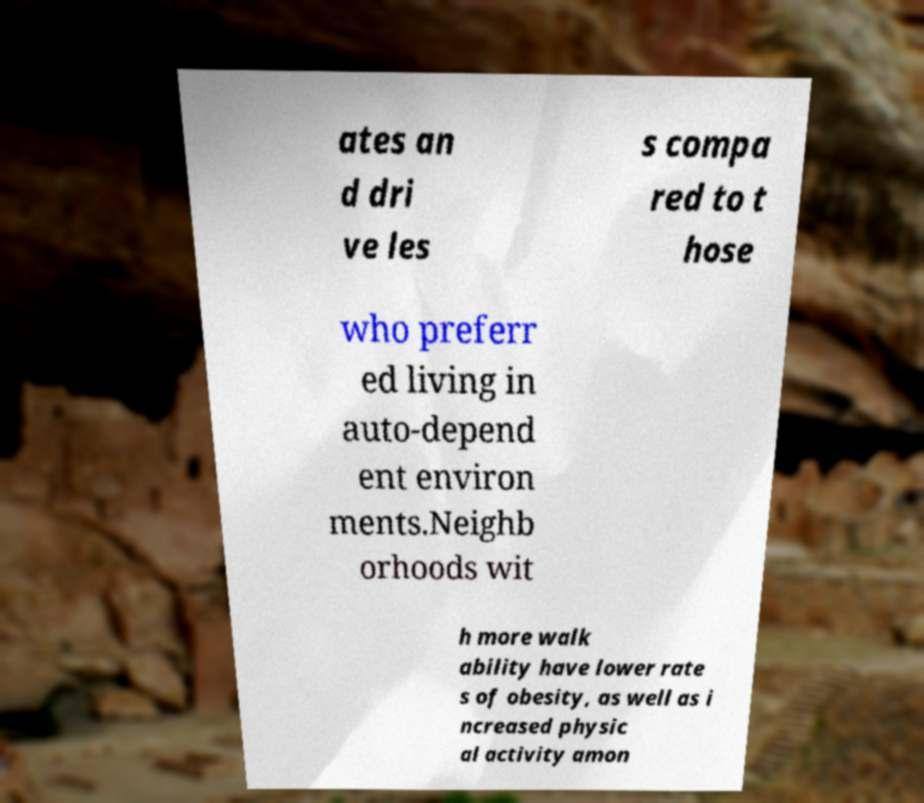What messages or text are displayed in this image? I need them in a readable, typed format. ates an d dri ve les s compa red to t hose who preferr ed living in auto-depend ent environ ments.Neighb orhoods wit h more walk ability have lower rate s of obesity, as well as i ncreased physic al activity amon 